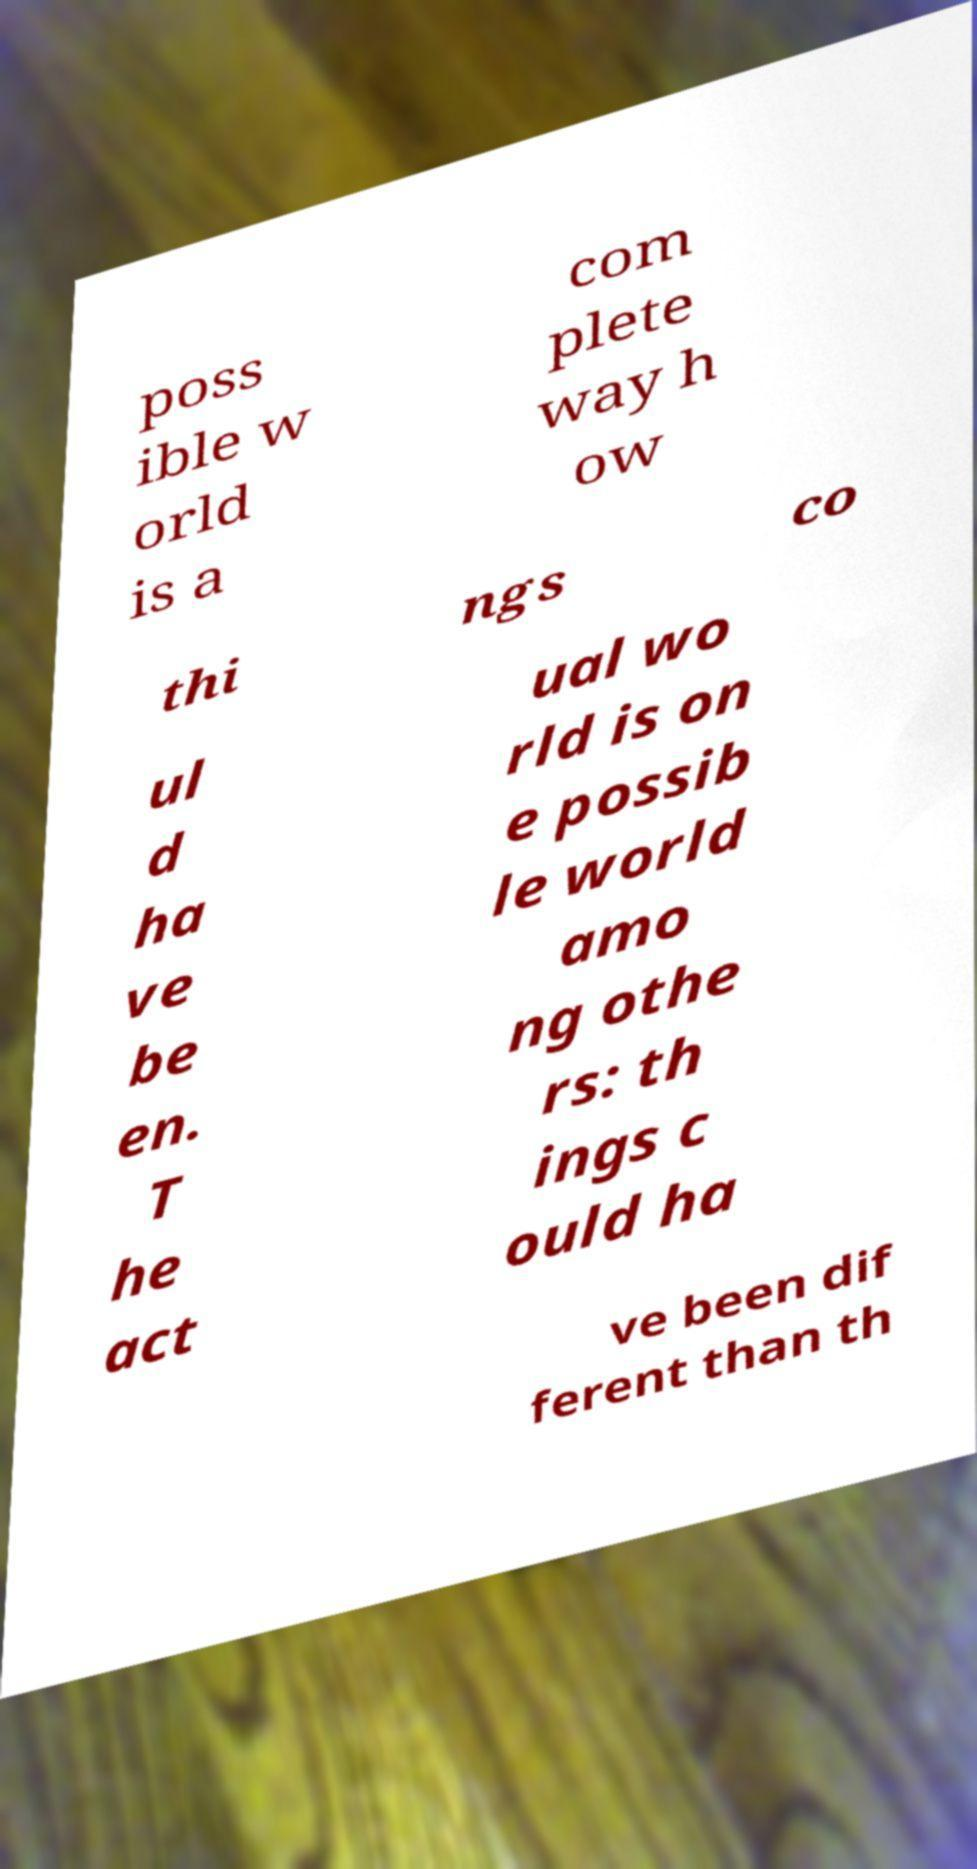What messages or text are displayed in this image? I need them in a readable, typed format. poss ible w orld is a com plete way h ow thi ngs co ul d ha ve be en. T he act ual wo rld is on e possib le world amo ng othe rs: th ings c ould ha ve been dif ferent than th 